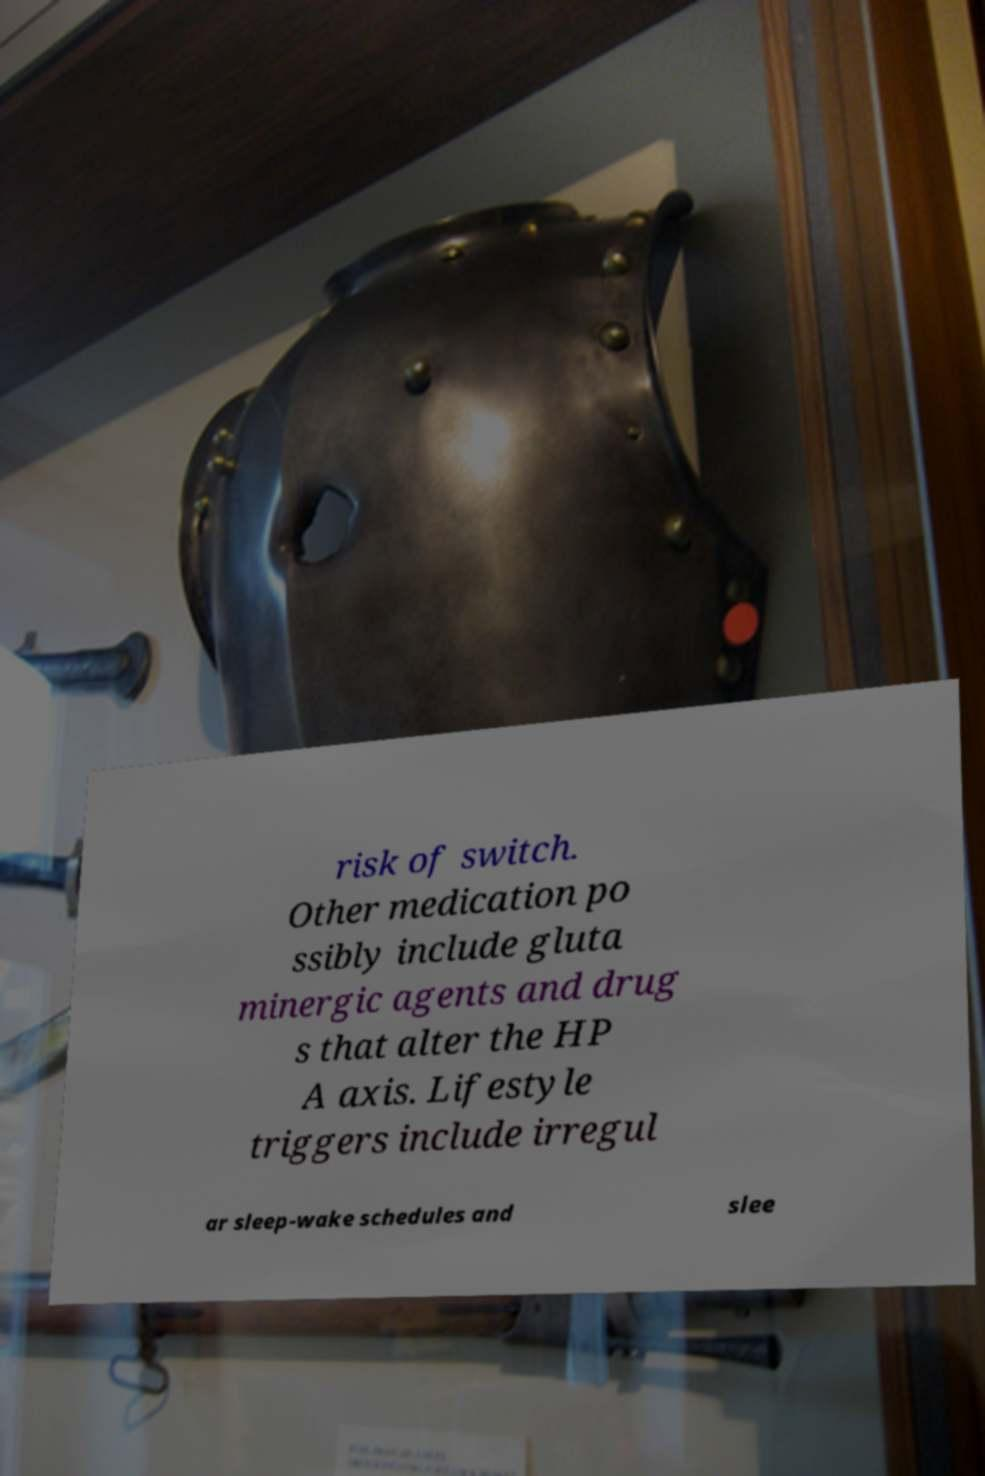There's text embedded in this image that I need extracted. Can you transcribe it verbatim? risk of switch. Other medication po ssibly include gluta minergic agents and drug s that alter the HP A axis. Lifestyle triggers include irregul ar sleep-wake schedules and slee 